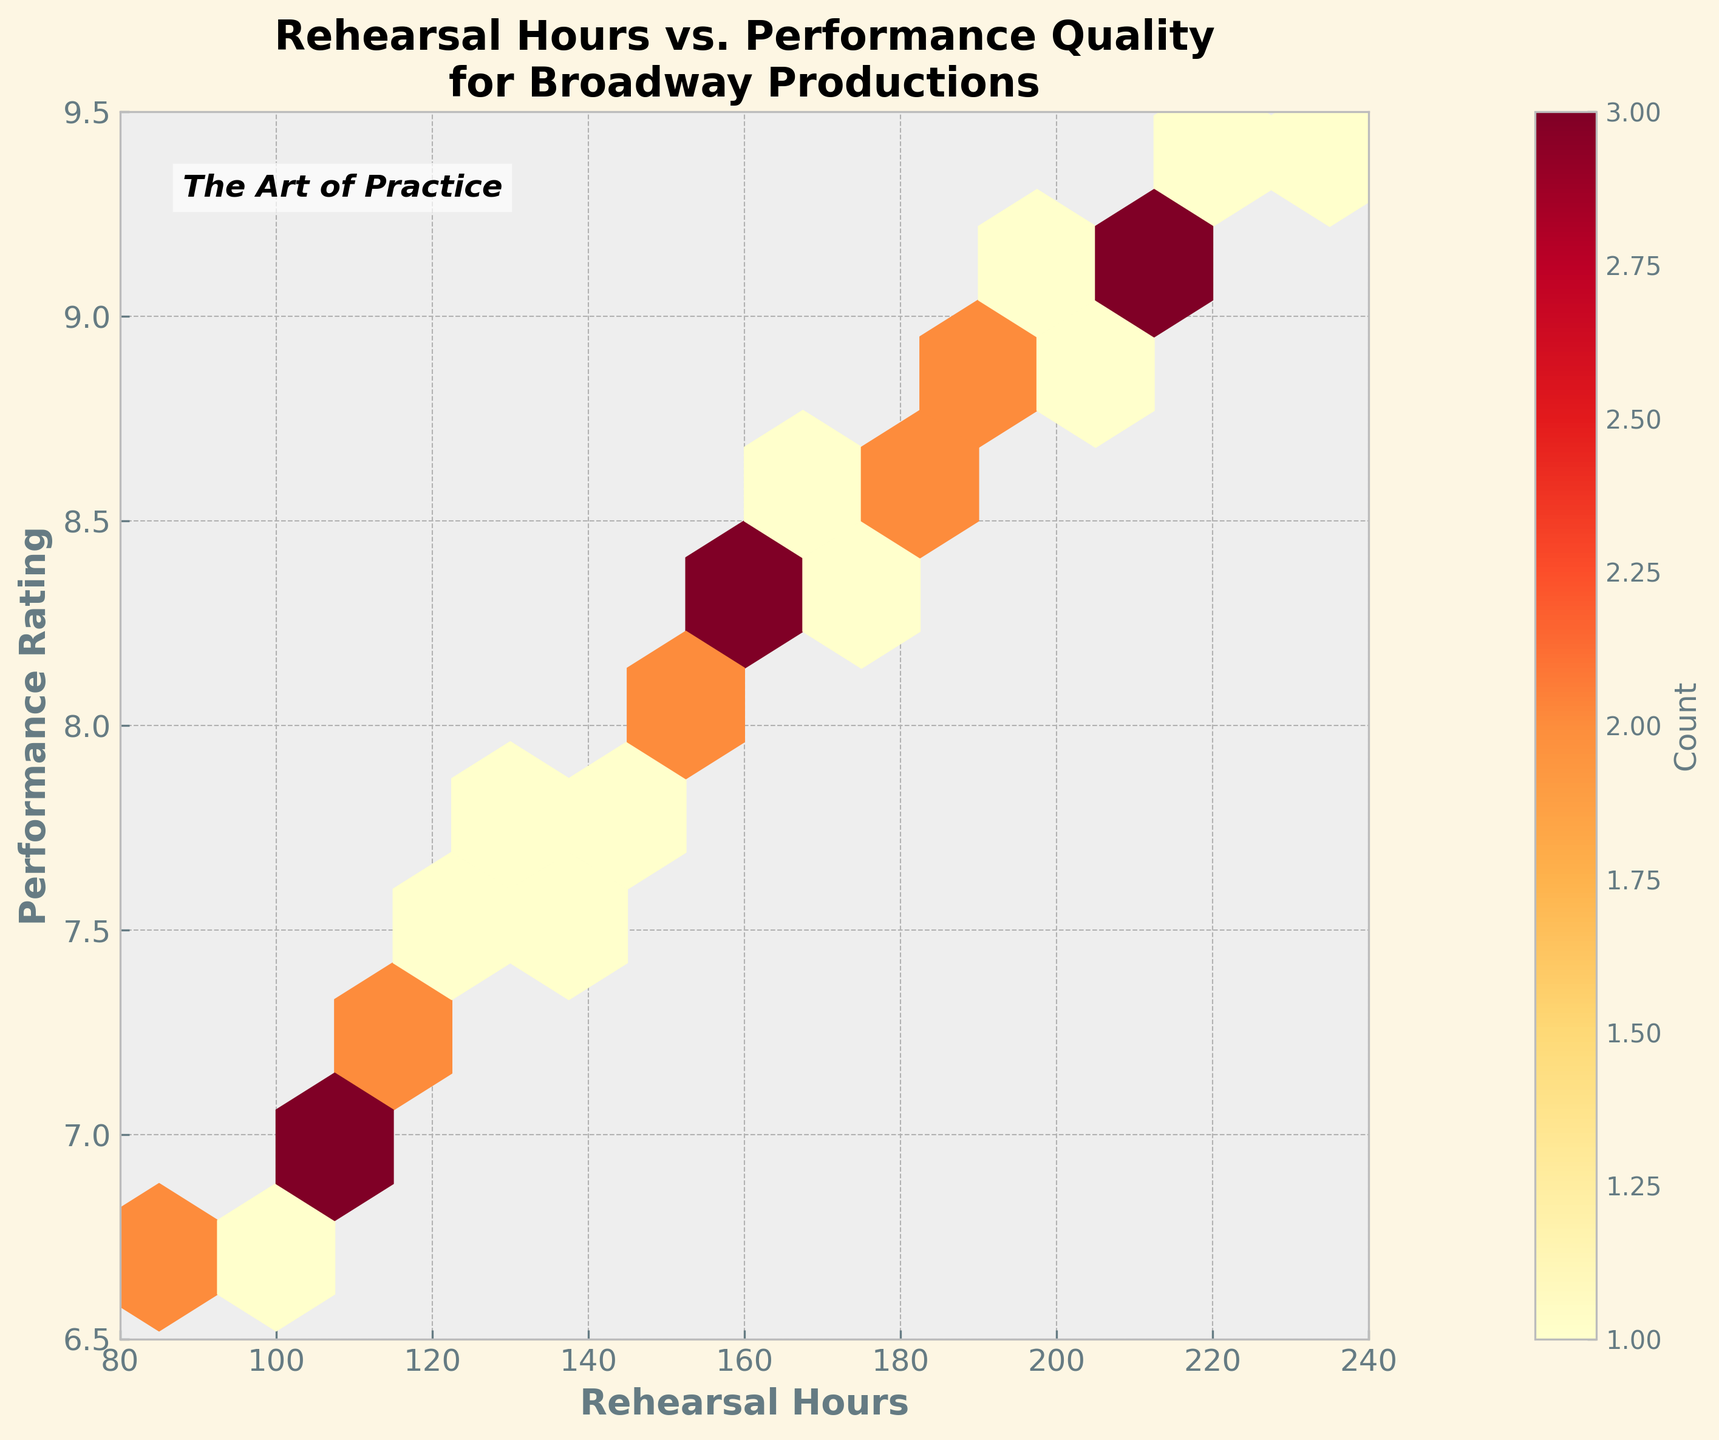How many distinct bins are visible in the plot? Count the number of hexagons on the plot. These hexagons are the bins, which contain data points distributed across the plot.
Answer: 10 What does the color gradient in the plot represent? The color gradient, ranging from light yellow to dark red, represents the count of data points within each bin. Brighter and darker colors indicate lower and higher densities, respectively.
Answer: Density of data points What is the range of Rehearsal Hours represented on the x-axis? Look at the x-axis's labeled tick marks to identify the minimum and maximum values.
Answer: 80 to 240 hours What is the highest Performance Rating recorded in the plot? Check the y-axis for the maximum value depicted within the plot's boundaries and note any points reaching the highest mark.
Answer: 9.4 Explain the relationship between Rehearsal Hours and Performance Rating. Visually inspect the plot. Notice how performance ratings tend to improve as rehearsal hours increase, forming an upward trend. Higher counts of data points cluster in bins where more rehearsal hours correlate with higher performance ratings.
Answer: Positive correlation Describe the notation found at the top-left of the plot. This notation is a textual element, stating "The Art of Practice," adding an interpretive or thematic element to the plot.
Answer: "The Art of Practice" Where is the highest count of data points located in the plot? Identify the darkest hexagon(s) representing the highest count of data points. Check their approximate position along the x and y-axes.
Answer: Around 200-215 Rehearsal Hours and 9.0-9.1 Performance Rating What insight can you derive from the hexbin plot about how much rehearsal influences performance quality on average? More rehearsal hours generally lead to higher performance ratings based on the upward trend and higher density of well-rated performances with longer rehearsal hours. Data points are more densely clustered toward the higher rating side as rehearsal hours increase.
Answer: More rehearsal leads to better performance Is there any evidence in the plot that suggests diminishing returns on rehearsal hours after reaching a certain number? Evaluate the distribution of performance ratings as rehearsal hours increase. Notice if the increments in ratings slow down or level off beyond certain hours, e.g., between 200-240 hours.
Answer: Yes, slight leveling above 200 hours 